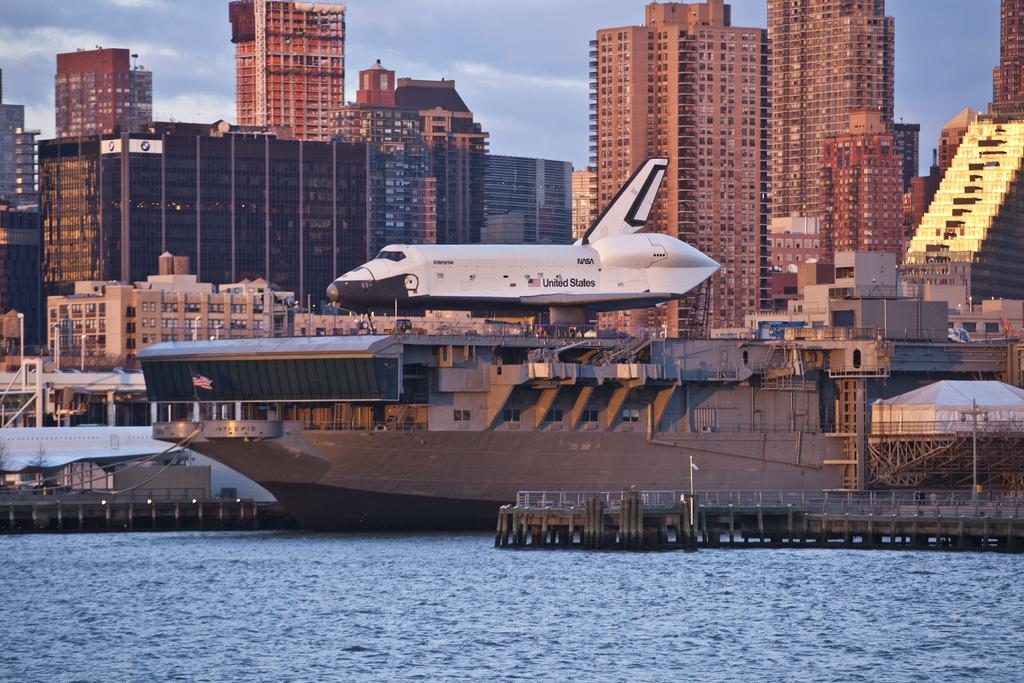What is the main subject in the middle of the image? There is a boat in the middle of the image. What is on the boat? There is an airplane on the boat. What is at the bottom of the image? There is water at the bottom of the image. What can be seen in the background of the image? There are buildings, electric poles, and the sky visible in the background of the image. What is the condition of the sky in the image? Clouds are present in the sky. Can you see a goose wearing a sock in the image? No, there is no goose or sock present in the image. 